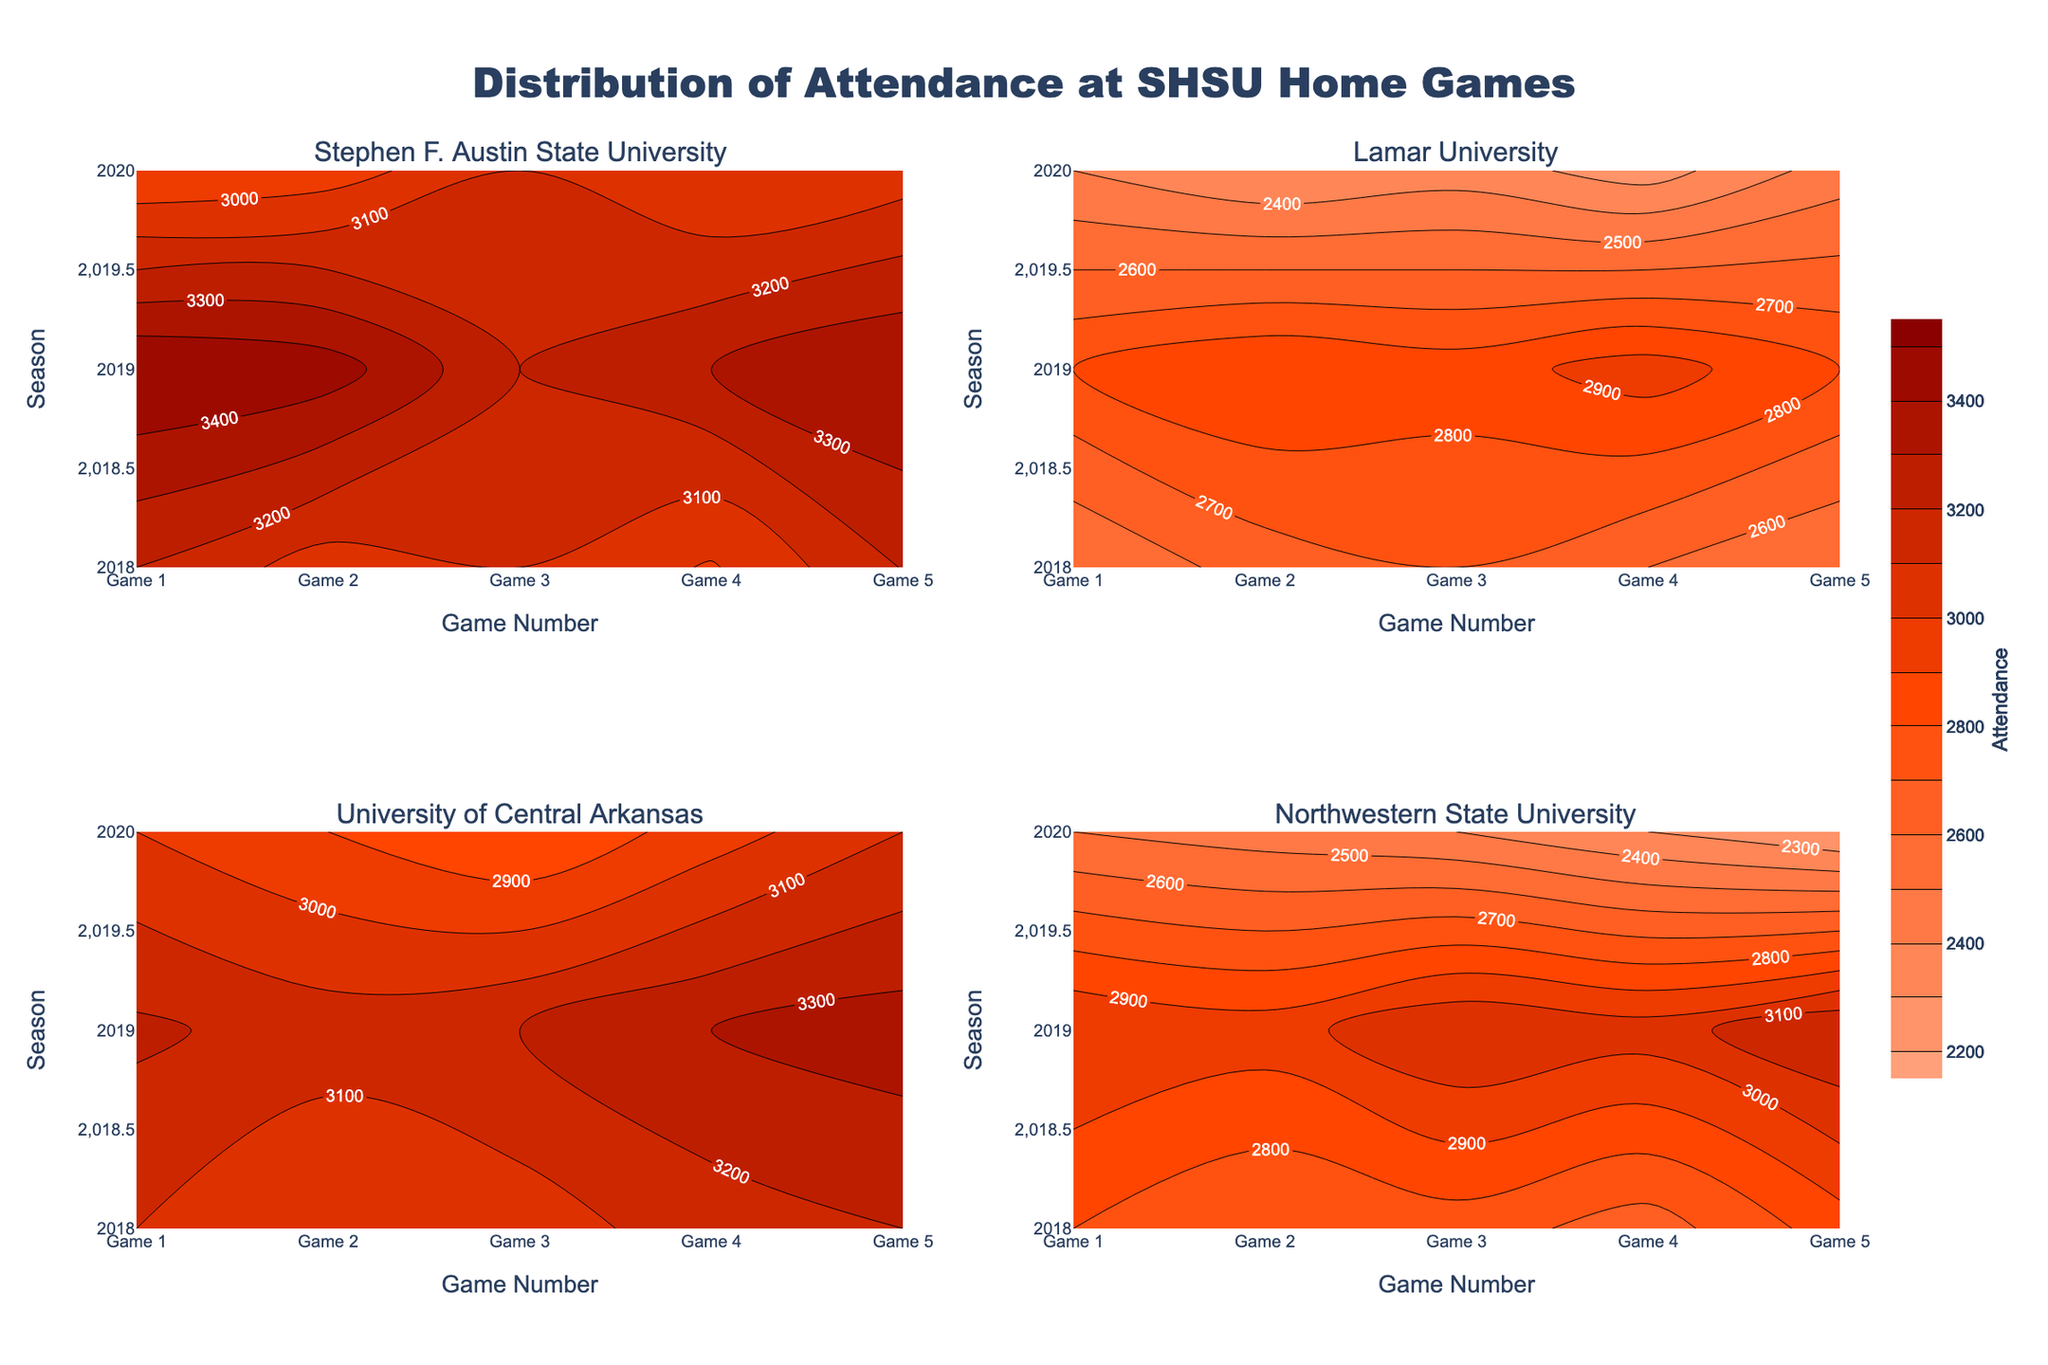What is the title of the figure? The title can be found at the top center of the figure, indicating what the plot represents.
Answer: Distribution of Attendance at SHSU Home Games Which opponent saw the highest attendance in 2019 across all games? Look at the subplots showing the contour plots for each opponent and identify the region with the highest attendance for the year 2019 in the y-axis.
Answer: Stephen F. Austin State University What is the lowest attendance recorded for Lamar University in the 2020 season? In the subplot for Lamar University, observe the contour lines for the season 2020 on the y-axis and find the lowest attendance value.
Answer: 2250 On average, which season had the highest attendance across all opponents? Calculate the average attendance for each season across all opponents and identify the season with the highest average.
Answer: 2019 Which game's attendance has the most variation for University of Central Arkansas in 2020? In the subplot for University of Central Arkansas, examine the contour lines for the year 2020, and note which game number has the widest range of attendance values.
Answer: Game 5 Comparing the attendance patterns, did Stephen F. Austin State University have higher attendance overall than Lamar University in 2018? Look at the subplots for both Stephen F. Austin State University and Lamar University in the year 2018 and compare the contour lines and shade intensities to determine which opponent had the higher attendance numbers.
Answer: Yes Did attendance for Northwestern State University increase or decrease from 2018 to 2020? Examine the subplot for Northwestern State University, looking at the changes in contour lines from the 2018 to the 2020 season across all games.
Answer: Decrease What is the range of attendance values for the 2019 season for all opponents? Identify the minimum and maximum attendance values represented in the contour plots for the year 2019 across all opponents and then calculate the difference.
Answer: 2300-3500 Which opponent shows more consistent attendance over the years, based on the contours? Compare the contour plots for each opponent to observe which has the most uniform contour lines over the three seasons.
Answer: University of Central Arkansas 